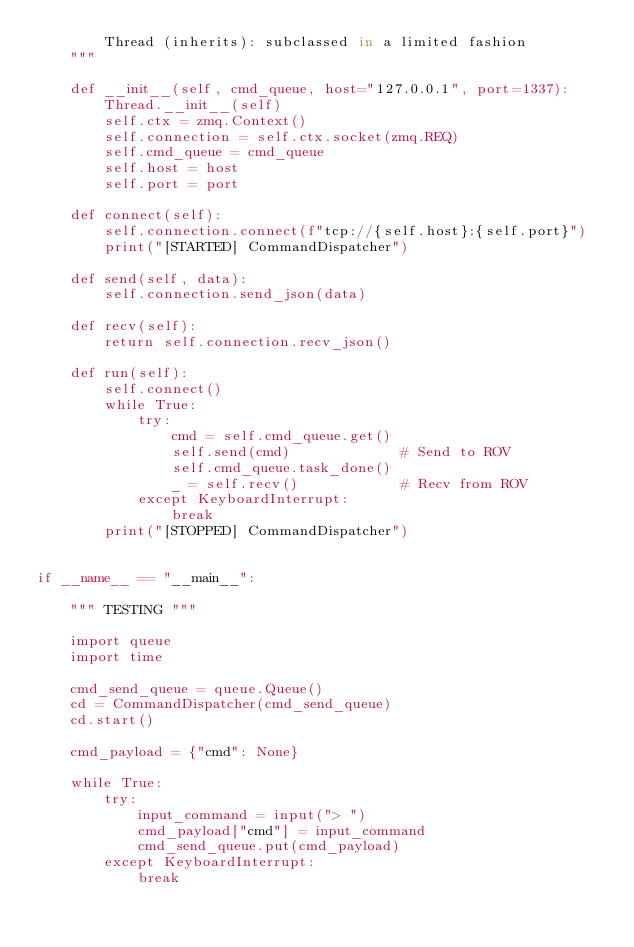<code> <loc_0><loc_0><loc_500><loc_500><_Python_>        Thread (inherits): subclassed in a limited fashion
    """

    def __init__(self, cmd_queue, host="127.0.0.1", port=1337):
        Thread.__init__(self)
        self.ctx = zmq.Context()
        self.connection = self.ctx.socket(zmq.REQ)
        self.cmd_queue = cmd_queue
        self.host = host
        self.port = port

    def connect(self):
        self.connection.connect(f"tcp://{self.host}:{self.port}")
        print("[STARTED] CommandDispatcher")

    def send(self, data):
        self.connection.send_json(data)

    def recv(self):
        return self.connection.recv_json()

    def run(self):
        self.connect()
        while True:
            try:
                cmd = self.cmd_queue.get()
                self.send(cmd)             # Send to ROV
                self.cmd_queue.task_done()
                _ = self.recv()            # Recv from ROV
            except KeyboardInterrupt:
                break
        print("[STOPPED] CommandDispatcher")


if __name__ == "__main__":

    """ TESTING """

    import queue
    import time

    cmd_send_queue = queue.Queue()
    cd = CommandDispatcher(cmd_send_queue)
    cd.start()

    cmd_payload = {"cmd": None}

    while True:
        try:
            input_command = input("> ")
            cmd_payload["cmd"] = input_command
            cmd_send_queue.put(cmd_payload)
        except KeyboardInterrupt:
            break
</code> 